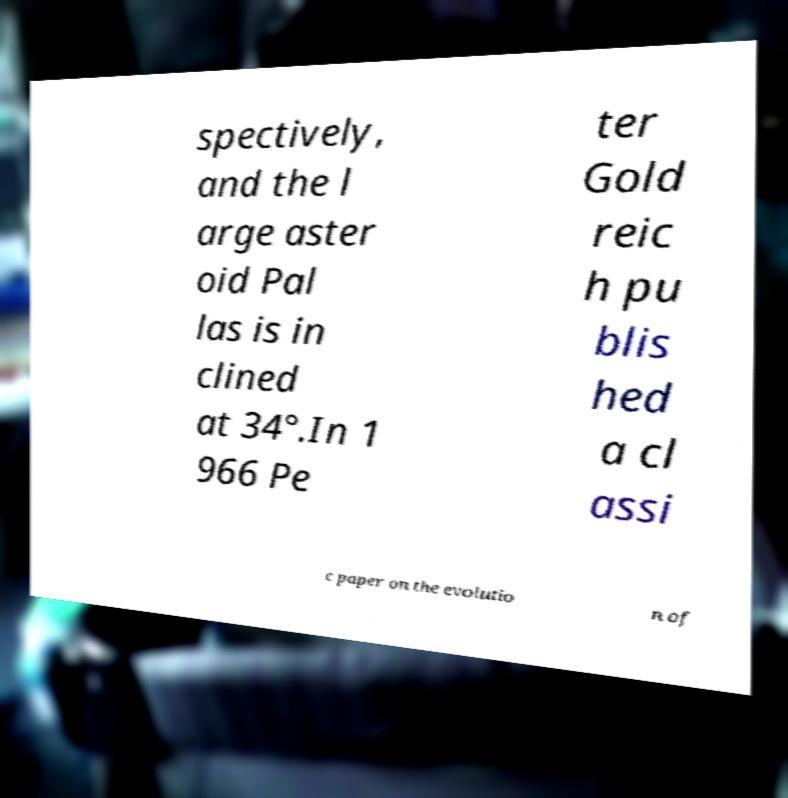Could you assist in decoding the text presented in this image and type it out clearly? spectively, and the l arge aster oid Pal las is in clined at 34°.In 1 966 Pe ter Gold reic h pu blis hed a cl assi c paper on the evolutio n of 